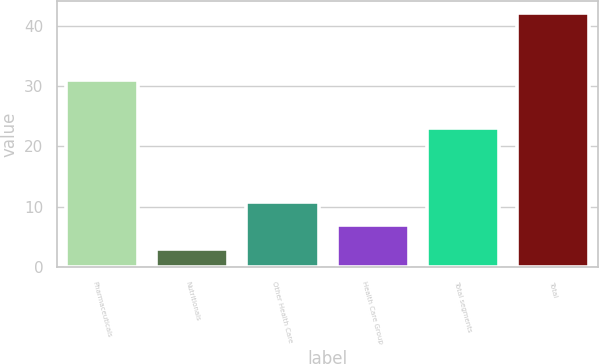<chart> <loc_0><loc_0><loc_500><loc_500><bar_chart><fcel>Pharmaceuticals<fcel>Nutritionals<fcel>Other Health Care<fcel>Health Care Group<fcel>Total segments<fcel>Total<nl><fcel>31<fcel>3<fcel>10.8<fcel>6.9<fcel>23<fcel>42<nl></chart> 